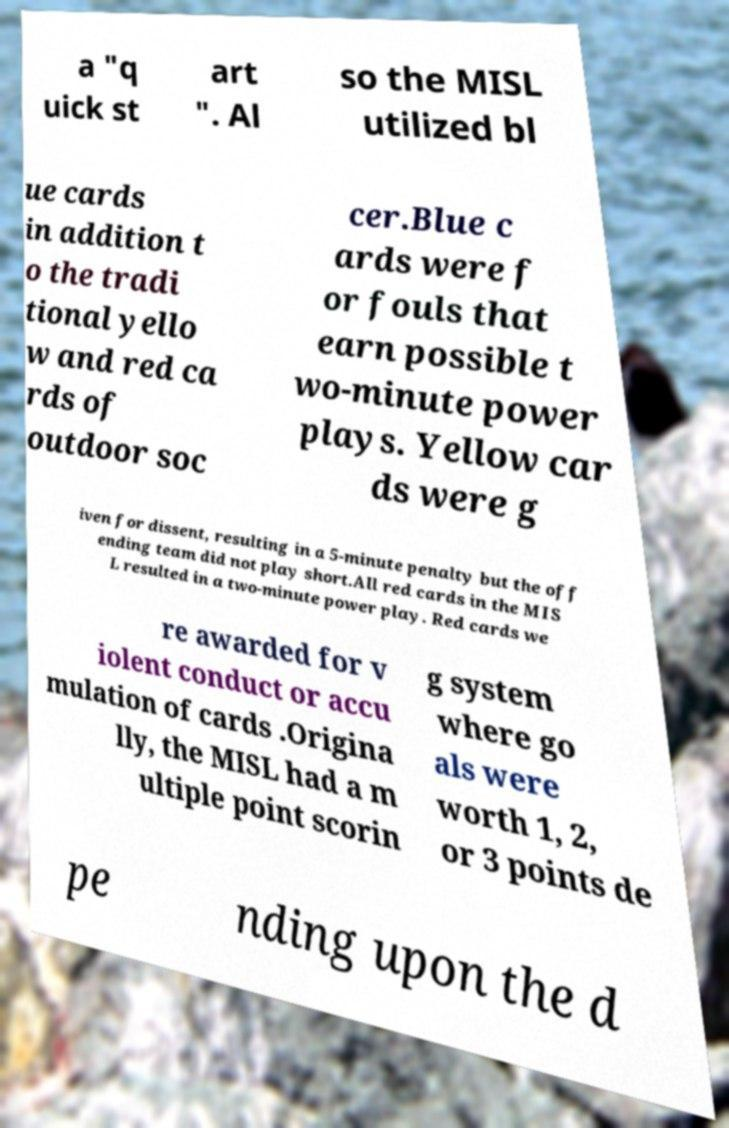Can you read and provide the text displayed in the image?This photo seems to have some interesting text. Can you extract and type it out for me? a "q uick st art ". Al so the MISL utilized bl ue cards in addition t o the tradi tional yello w and red ca rds of outdoor soc cer.Blue c ards were f or fouls that earn possible t wo-minute power plays. Yellow car ds were g iven for dissent, resulting in a 5-minute penalty but the off ending team did not play short.All red cards in the MIS L resulted in a two-minute power play. Red cards we re awarded for v iolent conduct or accu mulation of cards .Origina lly, the MISL had a m ultiple point scorin g system where go als were worth 1, 2, or 3 points de pe nding upon the d 